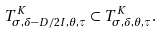<formula> <loc_0><loc_0><loc_500><loc_500>T ^ { K } _ { \sigma , \delta - D / 2 I , \theta , \tau } \subset T ^ { K } _ { \sigma , \delta , \theta , \tau } .</formula> 